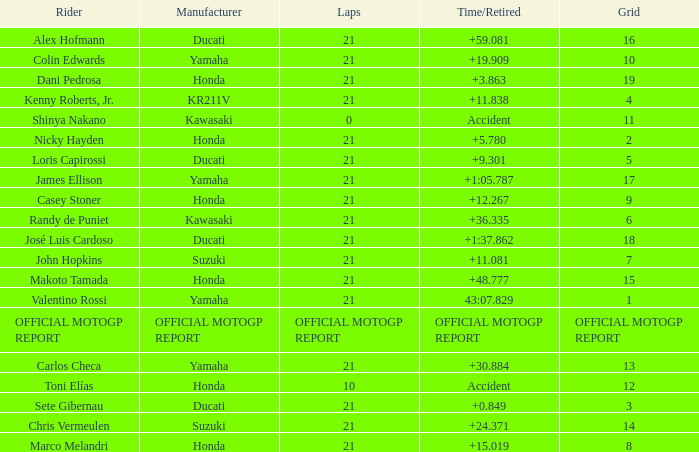WWhich rder had a vehicle manufactured by kr211v? Kenny Roberts, Jr. 